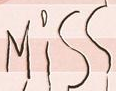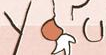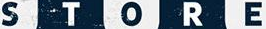What words are shown in these images in order, separated by a semicolon? Miss; you; STORE 